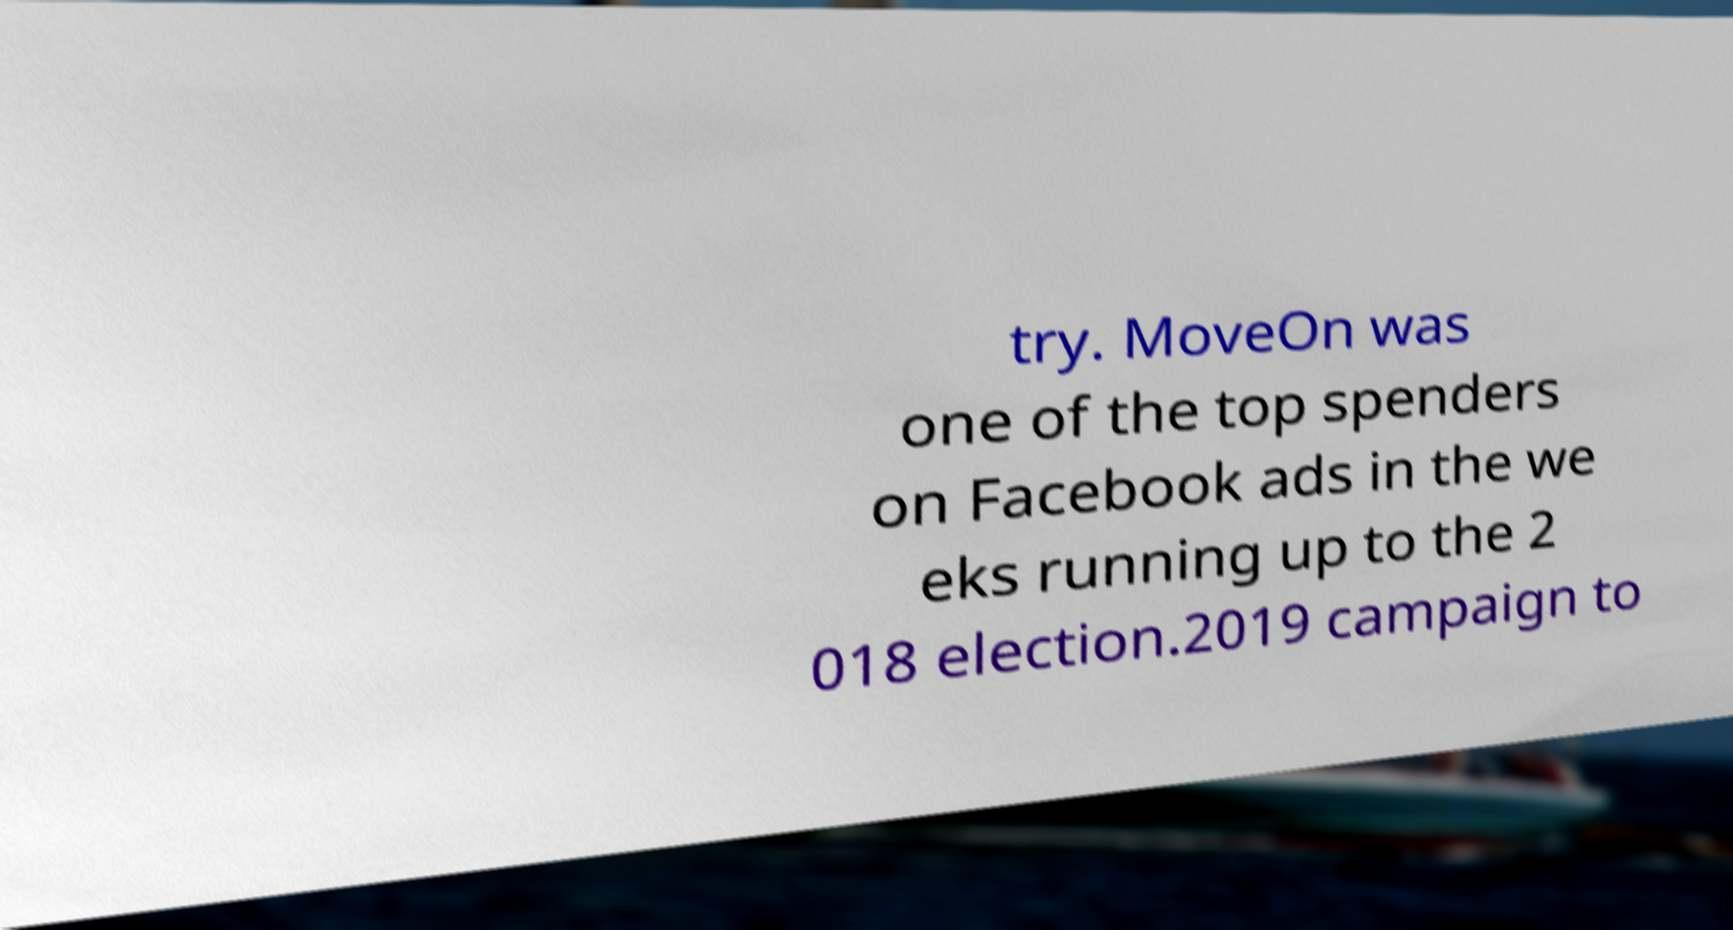What messages or text are displayed in this image? I need them in a readable, typed format. try. MoveOn was one of the top spenders on Facebook ads in the we eks running up to the 2 018 election.2019 campaign to 